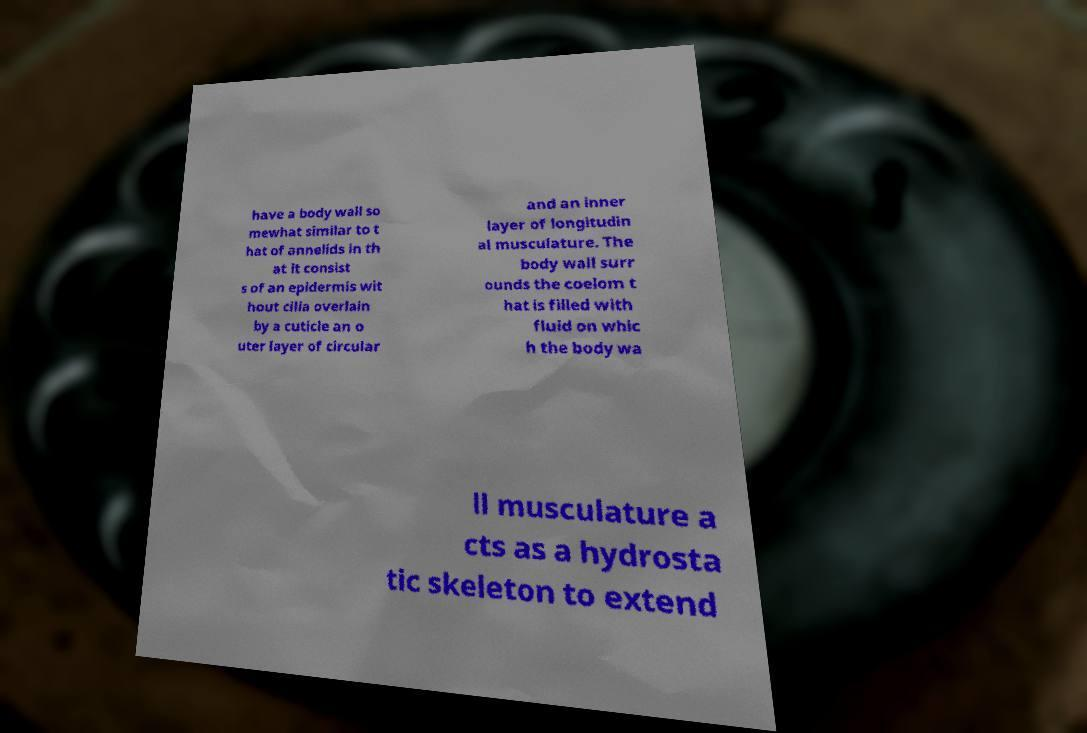Please identify and transcribe the text found in this image. have a body wall so mewhat similar to t hat of annelids in th at it consist s of an epidermis wit hout cilia overlain by a cuticle an o uter layer of circular and an inner layer of longitudin al musculature. The body wall surr ounds the coelom t hat is filled with fluid on whic h the body wa ll musculature a cts as a hydrosta tic skeleton to extend 